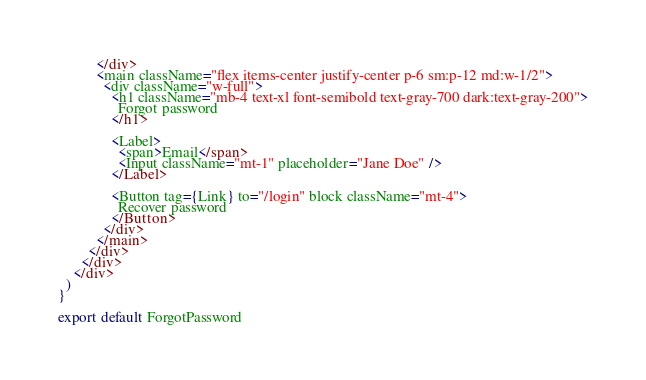Convert code to text. <code><loc_0><loc_0><loc_500><loc_500><_JavaScript_>          </div>
          <main className="flex items-center justify-center p-6 sm:p-12 md:w-1/2">
            <div className="w-full">
              <h1 className="mb-4 text-xl font-semibold text-gray-700 dark:text-gray-200">
                Forgot password
              </h1>

              <Label>
                <span>Email</span>
                <Input className="mt-1" placeholder="Jane Doe" />
              </Label>

              <Button tag={Link} to="/login" block className="mt-4">
                Recover password
              </Button>
            </div>
          </main>
        </div>
      </div>
    </div>
  )
}

export default ForgotPassword
</code> 